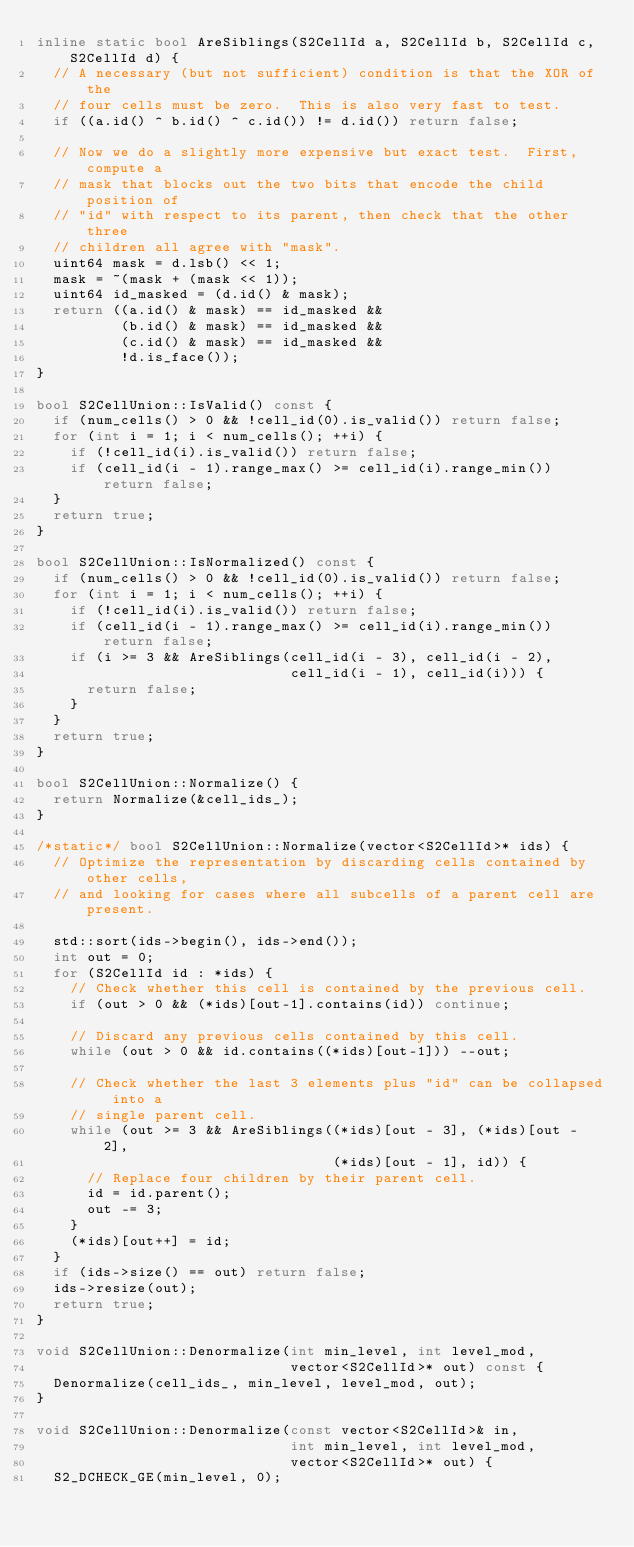<code> <loc_0><loc_0><loc_500><loc_500><_C++_>inline static bool AreSiblings(S2CellId a, S2CellId b, S2CellId c, S2CellId d) {
  // A necessary (but not sufficient) condition is that the XOR of the
  // four cells must be zero.  This is also very fast to test.
  if ((a.id() ^ b.id() ^ c.id()) != d.id()) return false;

  // Now we do a slightly more expensive but exact test.  First, compute a
  // mask that blocks out the two bits that encode the child position of
  // "id" with respect to its parent, then check that the other three
  // children all agree with "mask".
  uint64 mask = d.lsb() << 1;
  mask = ~(mask + (mask << 1));
  uint64 id_masked = (d.id() & mask);
  return ((a.id() & mask) == id_masked &&
          (b.id() & mask) == id_masked &&
          (c.id() & mask) == id_masked &&
          !d.is_face());
}

bool S2CellUnion::IsValid() const {
  if (num_cells() > 0 && !cell_id(0).is_valid()) return false;
  for (int i = 1; i < num_cells(); ++i) {
    if (!cell_id(i).is_valid()) return false;
    if (cell_id(i - 1).range_max() >= cell_id(i).range_min()) return false;
  }
  return true;
}

bool S2CellUnion::IsNormalized() const {
  if (num_cells() > 0 && !cell_id(0).is_valid()) return false;
  for (int i = 1; i < num_cells(); ++i) {
    if (!cell_id(i).is_valid()) return false;
    if (cell_id(i - 1).range_max() >= cell_id(i).range_min()) return false;
    if (i >= 3 && AreSiblings(cell_id(i - 3), cell_id(i - 2),
                              cell_id(i - 1), cell_id(i))) {
      return false;
    }
  }
  return true;
}

bool S2CellUnion::Normalize() {
  return Normalize(&cell_ids_);
}

/*static*/ bool S2CellUnion::Normalize(vector<S2CellId>* ids) {
  // Optimize the representation by discarding cells contained by other cells,
  // and looking for cases where all subcells of a parent cell are present.

  std::sort(ids->begin(), ids->end());
  int out = 0;
  for (S2CellId id : *ids) {
    // Check whether this cell is contained by the previous cell.
    if (out > 0 && (*ids)[out-1].contains(id)) continue;

    // Discard any previous cells contained by this cell.
    while (out > 0 && id.contains((*ids)[out-1])) --out;

    // Check whether the last 3 elements plus "id" can be collapsed into a
    // single parent cell.
    while (out >= 3 && AreSiblings((*ids)[out - 3], (*ids)[out - 2],
                                   (*ids)[out - 1], id)) {
      // Replace four children by their parent cell.
      id = id.parent();
      out -= 3;
    }
    (*ids)[out++] = id;
  }
  if (ids->size() == out) return false;
  ids->resize(out);
  return true;
}

void S2CellUnion::Denormalize(int min_level, int level_mod,
                              vector<S2CellId>* out) const {
  Denormalize(cell_ids_, min_level, level_mod, out);
}

void S2CellUnion::Denormalize(const vector<S2CellId>& in,
                              int min_level, int level_mod,
                              vector<S2CellId>* out) {
  S2_DCHECK_GE(min_level, 0);</code> 